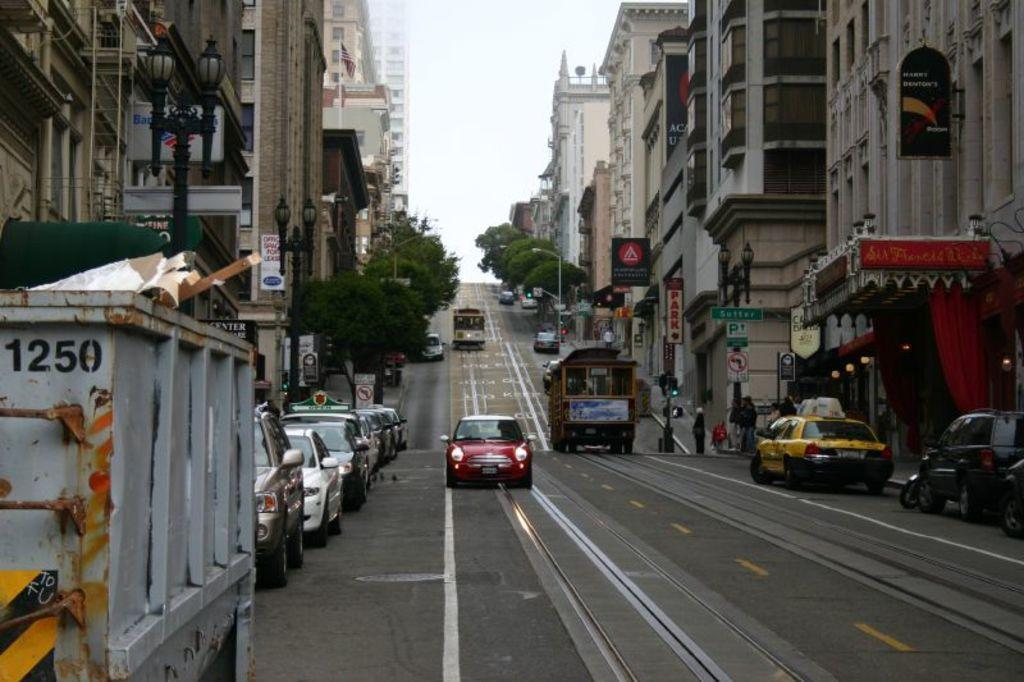<image>
Render a clear and concise summary of the photo. A red cars is driving up the street and is approaching dumpster 1250. 